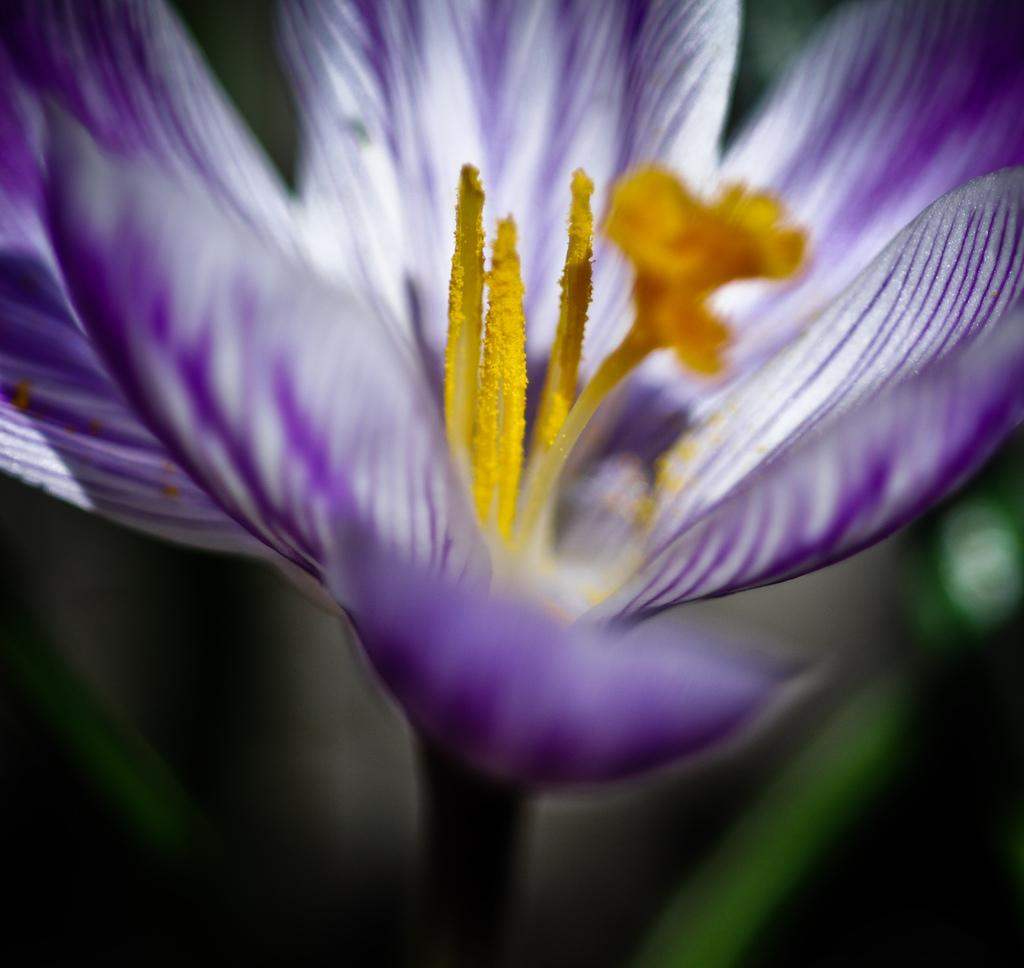What is the main subject of the image? The main subject of the image is a flower. Can you describe the color pattern on the flower's petals? The flower has violet color lines and white color lines on its petals. What can be found in the center of the flower? There is a stamen in the middle of the flower. What color is the stamen? The stamen is yellow in color. How many cups are placed next to the flower in the image? There are no cups present in the image; it features a flower. 